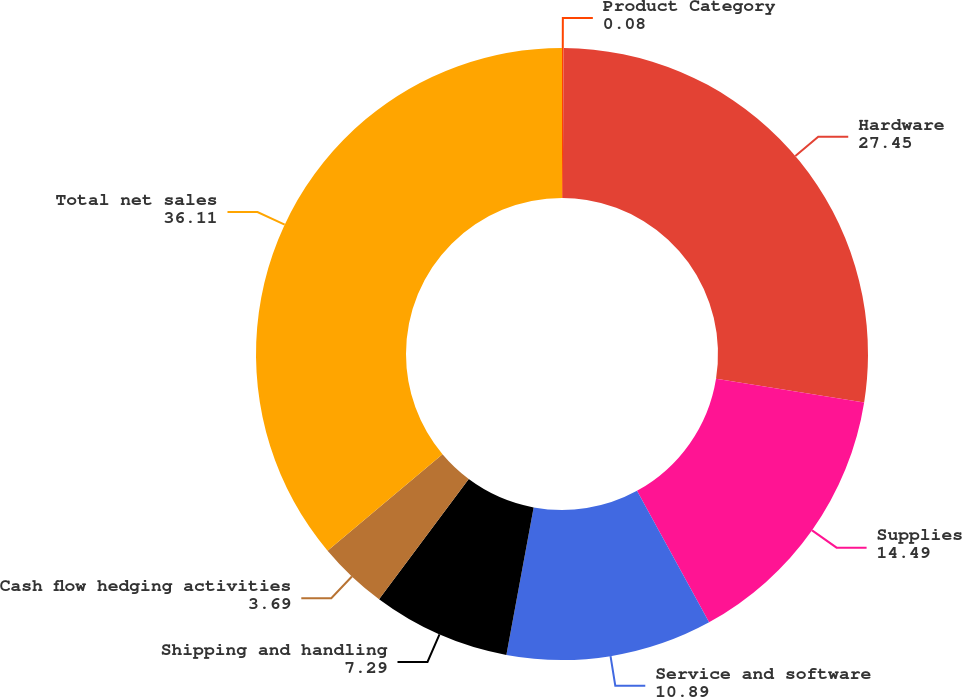Convert chart to OTSL. <chart><loc_0><loc_0><loc_500><loc_500><pie_chart><fcel>Product Category<fcel>Hardware<fcel>Supplies<fcel>Service and software<fcel>Shipping and handling<fcel>Cash flow hedging activities<fcel>Total net sales<nl><fcel>0.08%<fcel>27.45%<fcel>14.49%<fcel>10.89%<fcel>7.29%<fcel>3.69%<fcel>36.11%<nl></chart> 